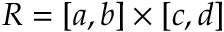<formula> <loc_0><loc_0><loc_500><loc_500>R = [ a , b ] \times [ c , d ]</formula> 